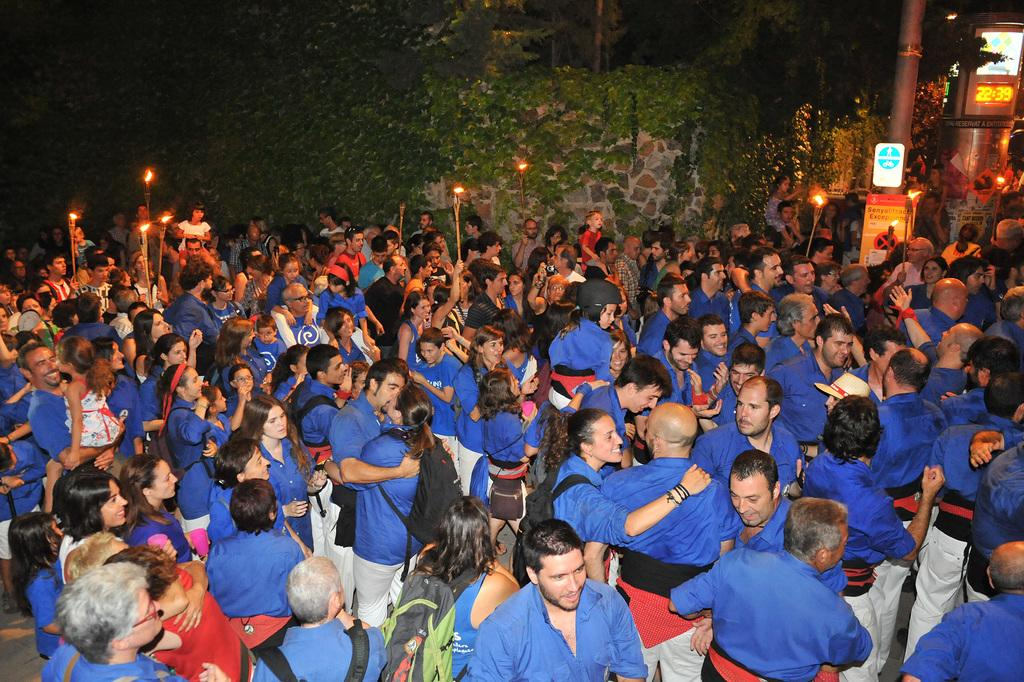What is the main subject of the image? The main subject of the image is a crowd of people. Are there any specific objects or features in the image? Yes, there are candles, a wall, a pole, and a display on the right side of the image. What type of volleyball game is being played in the image? There is no volleyball game present in the image. How many people are playing volleyball in the image? There is no volleyball game present in the image, so it is not possible to determine how many people might be playing. 